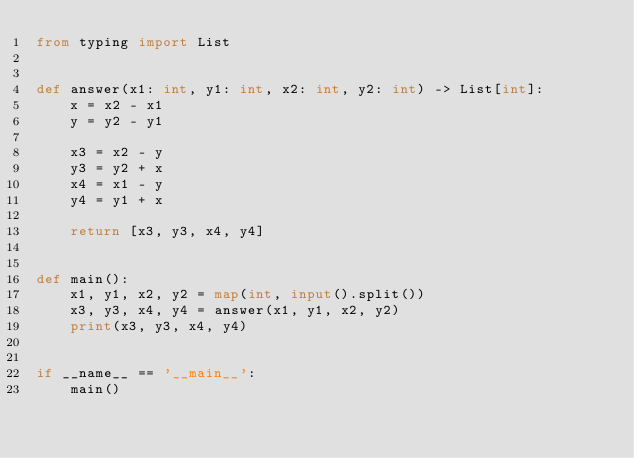<code> <loc_0><loc_0><loc_500><loc_500><_Python_>from typing import List


def answer(x1: int, y1: int, x2: int, y2: int) -> List[int]:
    x = x2 - x1
    y = y2 - y1

    x3 = x2 - y
    y3 = y2 + x
    x4 = x1 - y
    y4 = y1 + x

    return [x3, y3, x4, y4]


def main():
    x1, y1, x2, y2 = map(int, input().split())
    x3, y3, x4, y4 = answer(x1, y1, x2, y2)
    print(x3, y3, x4, y4)


if __name__ == '__main__':
    main()
</code> 